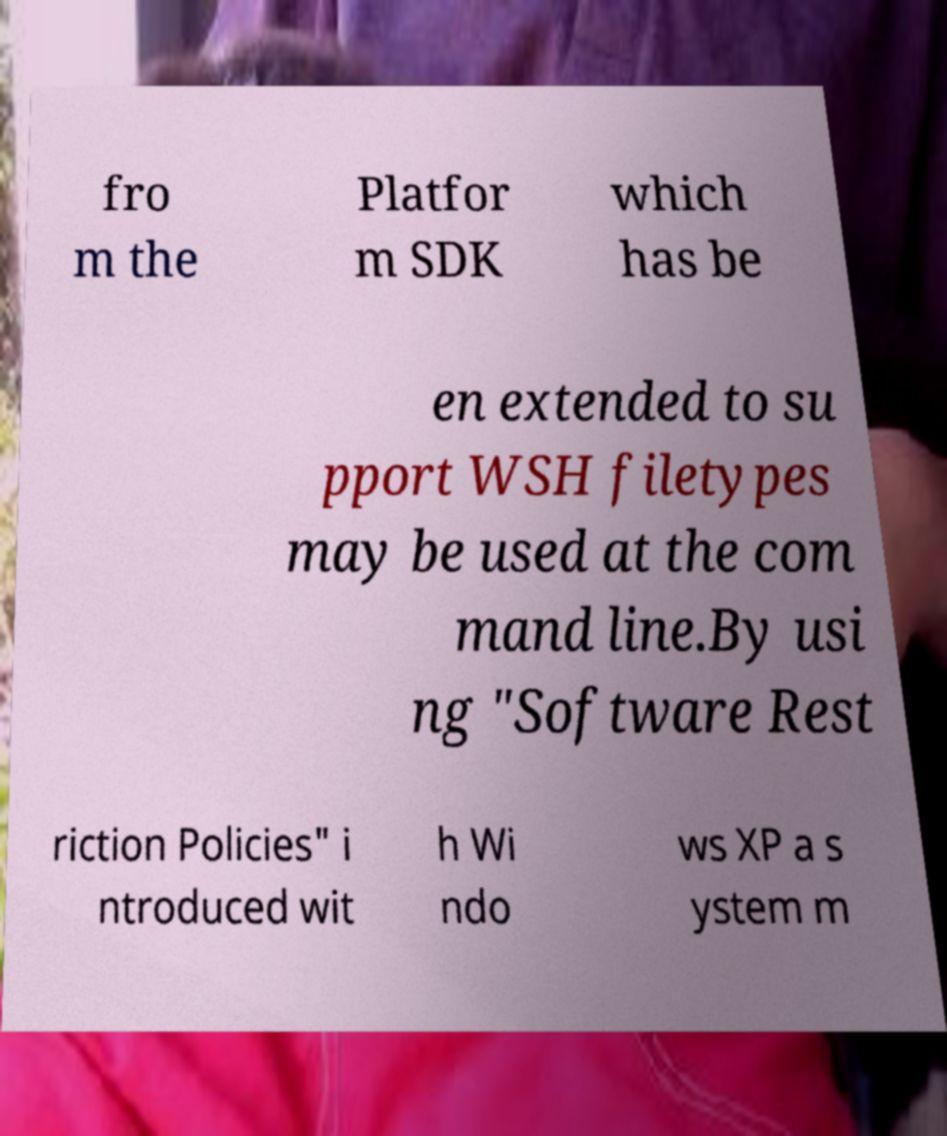Can you read and provide the text displayed in the image?This photo seems to have some interesting text. Can you extract and type it out for me? fro m the Platfor m SDK which has be en extended to su pport WSH filetypes may be used at the com mand line.By usi ng "Software Rest riction Policies" i ntroduced wit h Wi ndo ws XP a s ystem m 